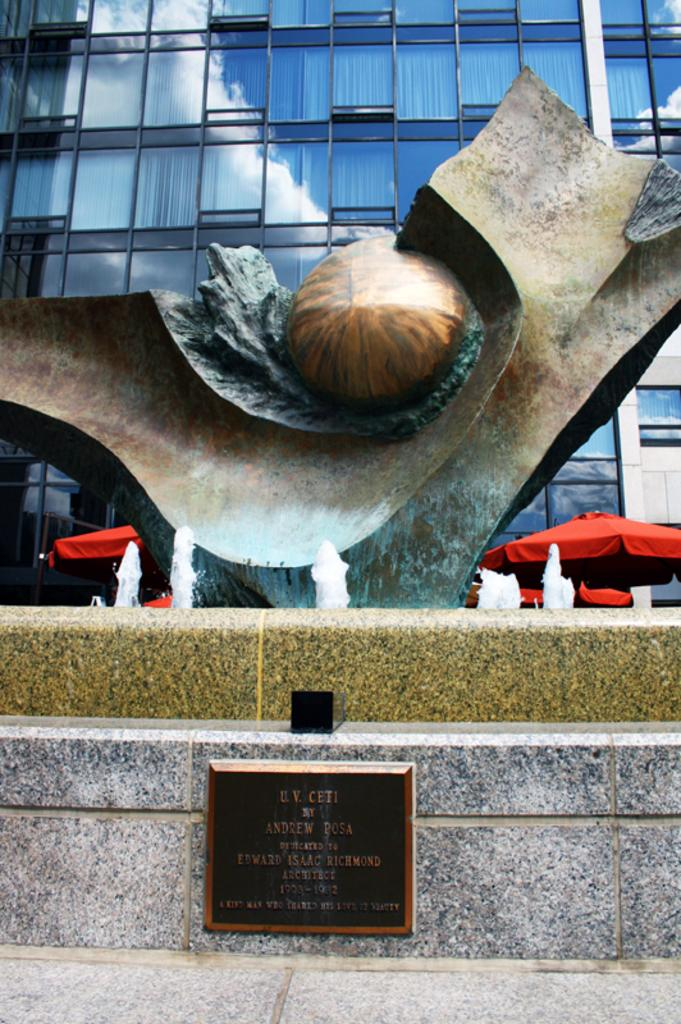What is the main subject in the fountain in the image? There is a sculpture in the fountain. What is located at the bottom of the image? There is a stone plate at the bottom of the image. What type of structure can be seen in the image? There is a building in the image. What objects are present for protection from the elements? There are umbrellas in the image. Where is the nest of the bird that is dropping feathers in the image? There is no bird or nest present in the image, and therefore no feathers are being dropped. 